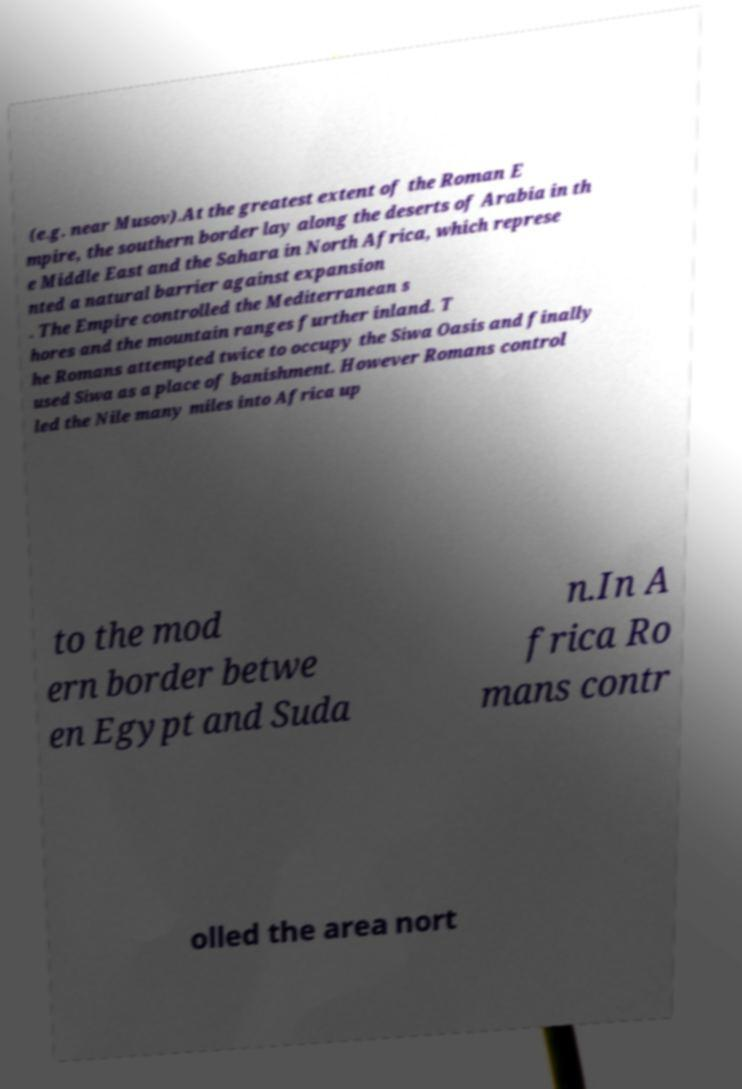Can you accurately transcribe the text from the provided image for me? (e.g. near Musov).At the greatest extent of the Roman E mpire, the southern border lay along the deserts of Arabia in th e Middle East and the Sahara in North Africa, which represe nted a natural barrier against expansion . The Empire controlled the Mediterranean s hores and the mountain ranges further inland. T he Romans attempted twice to occupy the Siwa Oasis and finally used Siwa as a place of banishment. However Romans control led the Nile many miles into Africa up to the mod ern border betwe en Egypt and Suda n.In A frica Ro mans contr olled the area nort 